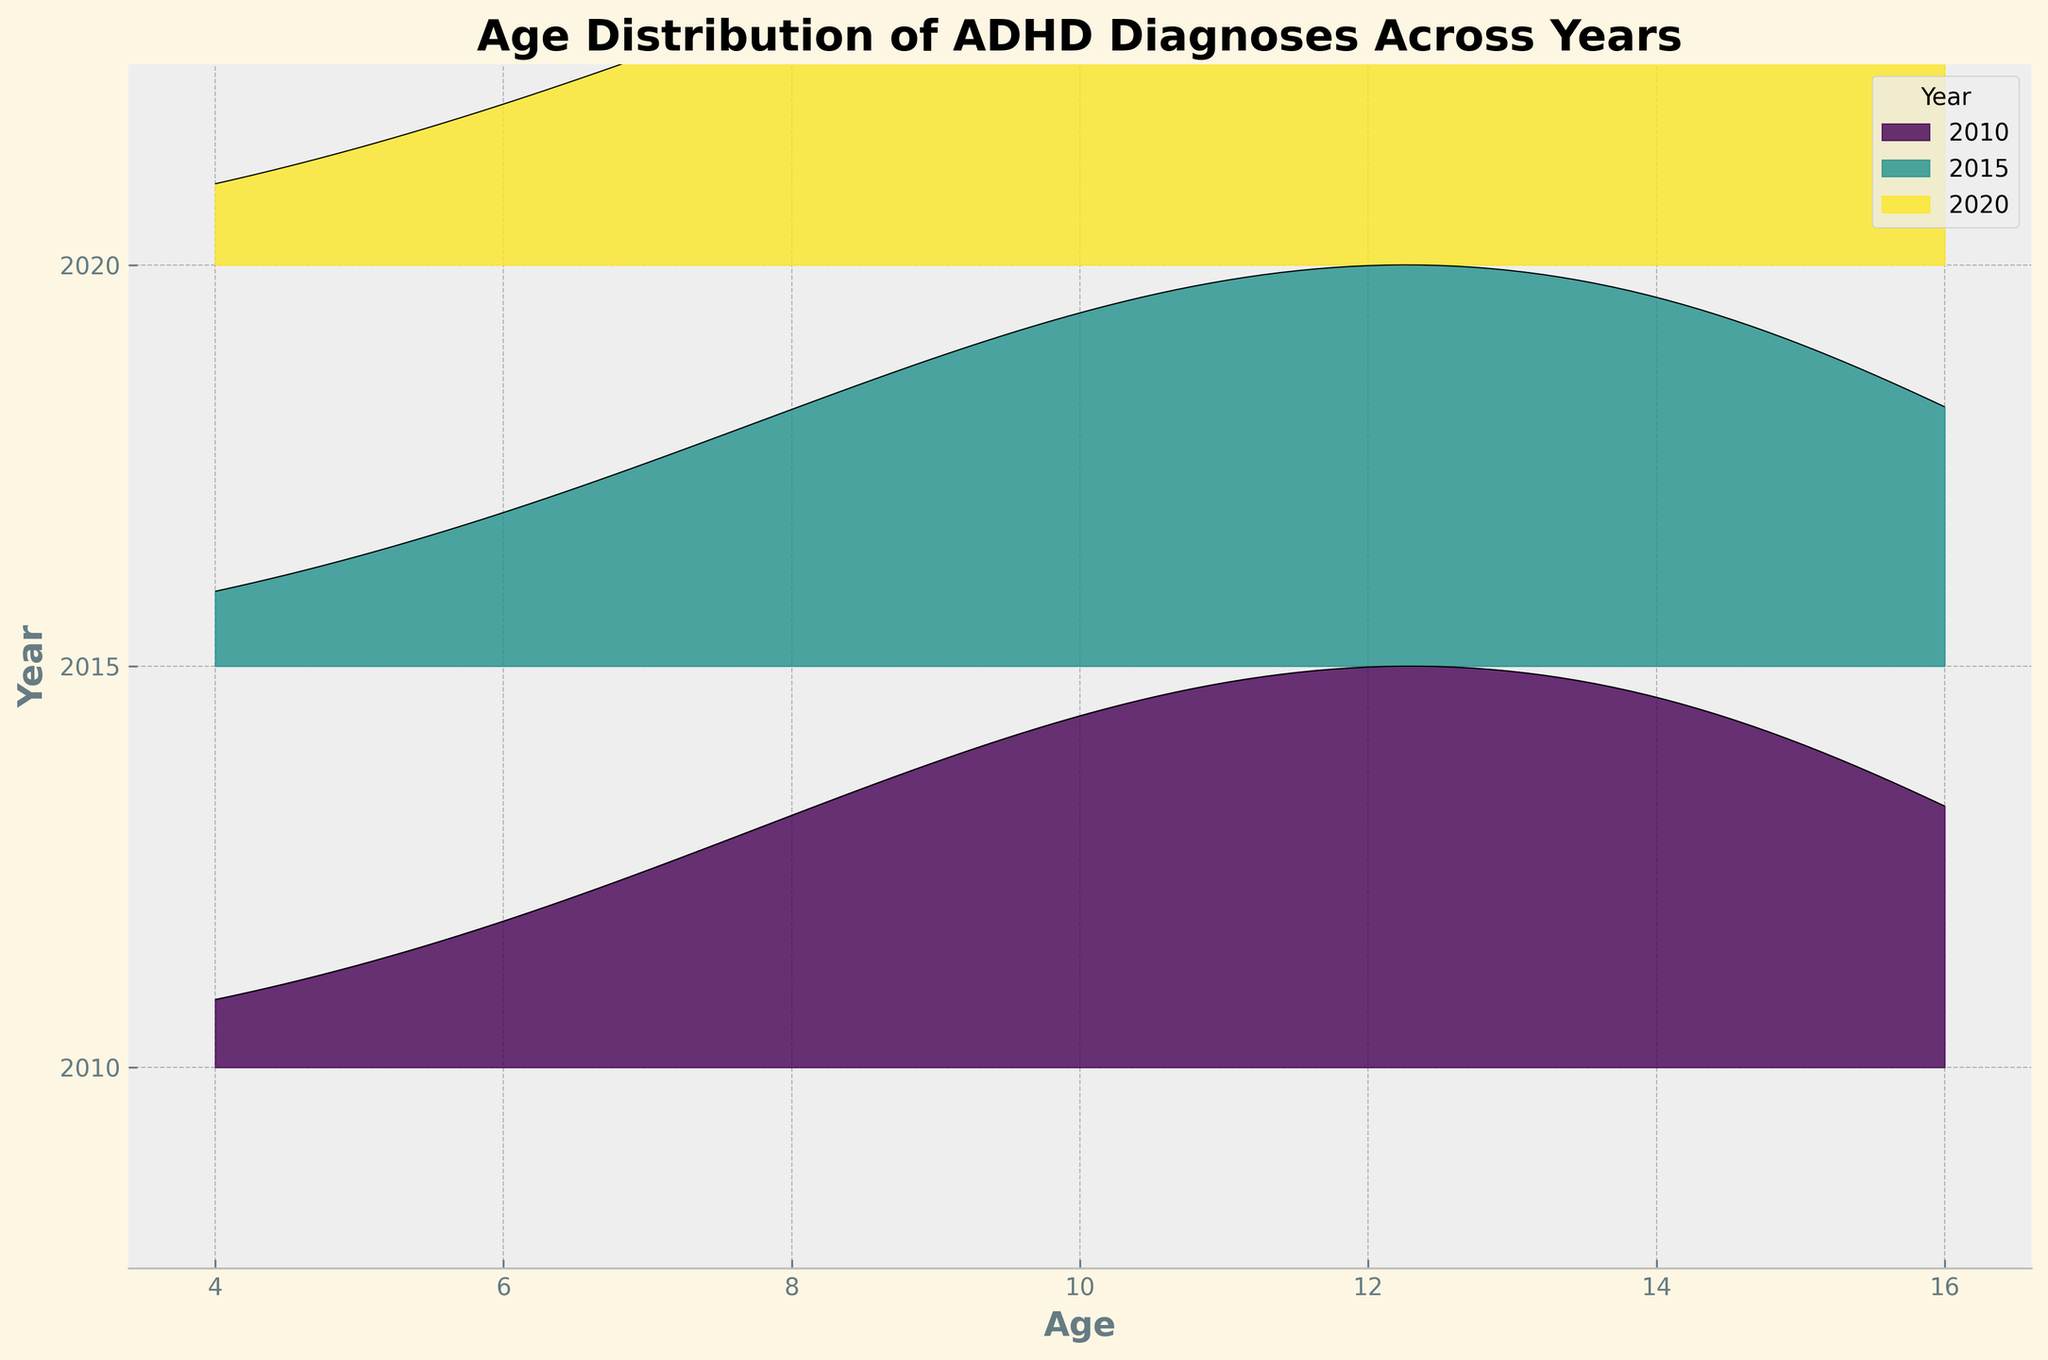Which year has the highest frequency of ADHD diagnoses at age 12? Examining the ridgeline plot, the peak frequency for age 12 in 2020 is higher than the peaks for the same age in 2010 and 2015.
Answer: 2020 What is the x-axis label of the figure? The figure has been labeled, and the x-axis clearly states what it represents.
Answer: Age Which year shows the most variation in ADHD diagnoses across ages? By observing the spread and height of curves for each year, the year with the widest and highest variations is 2020.
Answer: 2020 In which year was the frequency of ADHD diagnoses at age 10 the lowest? Looking at the height of peaks for age 10 in different years, 2010 has the smallest height.
Answer: 2010 What's the general trend in the age distribution over the years? The ridgeline plot shows that frequency increases with age, peaking around early adolescence, and then declines. Over the years, this pattern becomes more pronounced and higher in magnitude.
Answer: Increases with age Which color represents the year 2010 in the plot? The ridgeline plot uses different colors for different years, and by looking at the color legend, the year 2010 is represented by a certain shade.
Answer: [Specify the exact color present in the plot, typically a shade from viridis color map] Does any year show a modal shift towards younger children compared to others? Observing the peaks for younger ages, none of the years show a significant modal shift towards younger ages as higher peaks are still visible in older age groups.
Answer: No How does the distribution at age 8 in 2010 compare to that in 2015? The peaks for age 8 in both years need to be compared, showing that 2015 has a higher frequency as the peak is taller.
Answer: Higher in 2015 Which year has the widest spread in the distribution of ADHD diagnoses? By observing the spread of the KDE curves, the year with the widest spread from youngest to oldest age groups should be identified.
Answer: 2020 What is the primary trend noticeable in the incidence of ADHD from 4 to 16 years over the years? Examining the ridgeline plot reveals an increasing trend in ADHD incidence peaking around adolescence and then slightly decreasing. This trend becomes more pronounced from 2010 to 2020.
Answer: Increasing with age, peaking in adolescence 